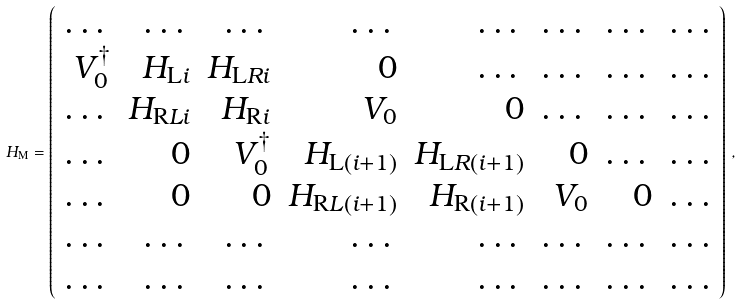<formula> <loc_0><loc_0><loc_500><loc_500>H _ { \mathrm M } = \left ( \begin{array} [ h ] { r r r r r r r r } \dots & \dots & \dots & \dots & \dots & \dots & \dots & \dots \\ V _ { 0 } ^ { \dagger } & H _ { \mathrm L i } & H _ { \mathrm L R i } & 0 & \dots & \dots & \dots & \dots \\ \dots & H _ { \mathrm R L i } & H _ { \mathrm R i } & V _ { 0 } & 0 & \dots & \dots & \dots \\ \dots & 0 & V _ { 0 } ^ { \dagger } & H _ { \mathrm L ( i + 1 ) } & H _ { \mathrm L R ( i + 1 ) } & 0 & \dots & \dots \\ \dots & 0 & 0 & H _ { \mathrm R L ( i + 1 ) } & H _ { \mathrm R ( i + 1 ) } & V _ { 0 } & 0 & \dots \\ \dots & \dots & \dots & \dots & \dots & \dots & \dots & \dots \\ \dots & \dots & \dots & \dots & \dots & \dots & \dots & \dots \\ \end{array} \right ) { \, } ,</formula> 